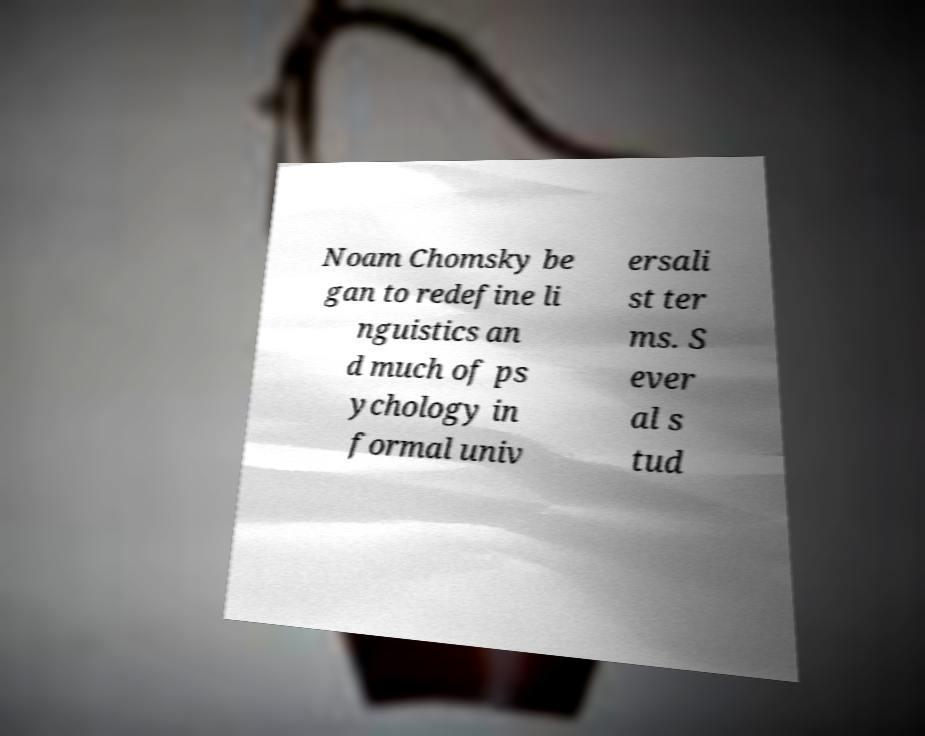There's text embedded in this image that I need extracted. Can you transcribe it verbatim? Noam Chomsky be gan to redefine li nguistics an d much of ps ychology in formal univ ersali st ter ms. S ever al s tud 